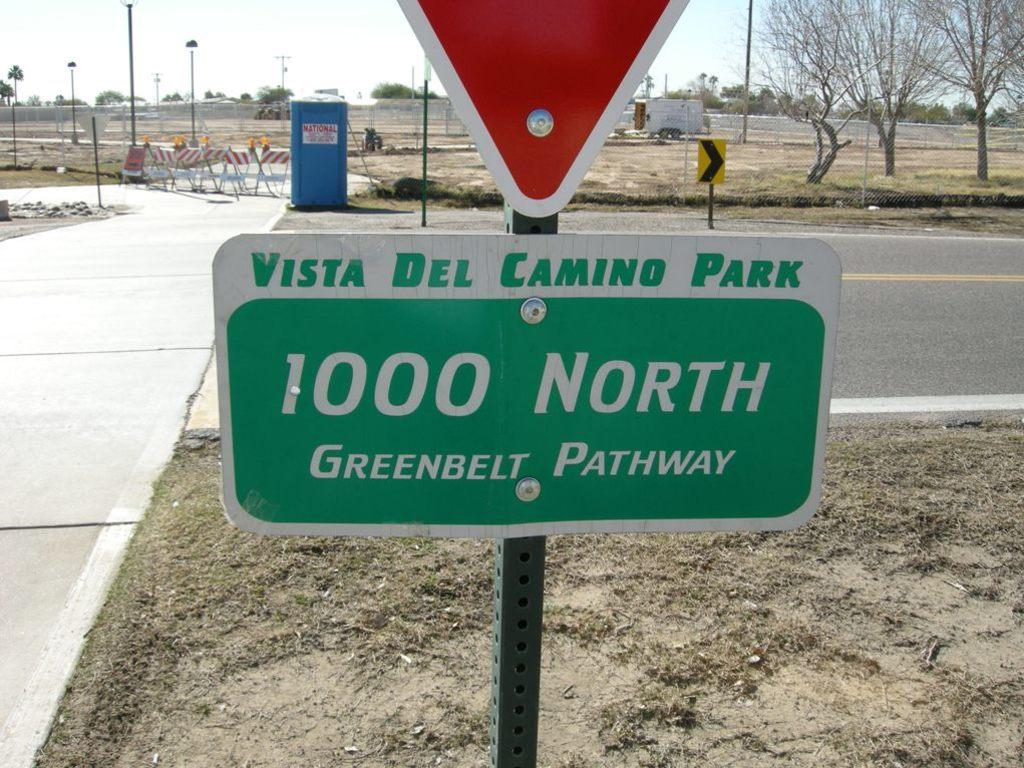<image>
Offer a succinct explanation of the picture presented. A green and white sign for Vista Del Camino Park. 